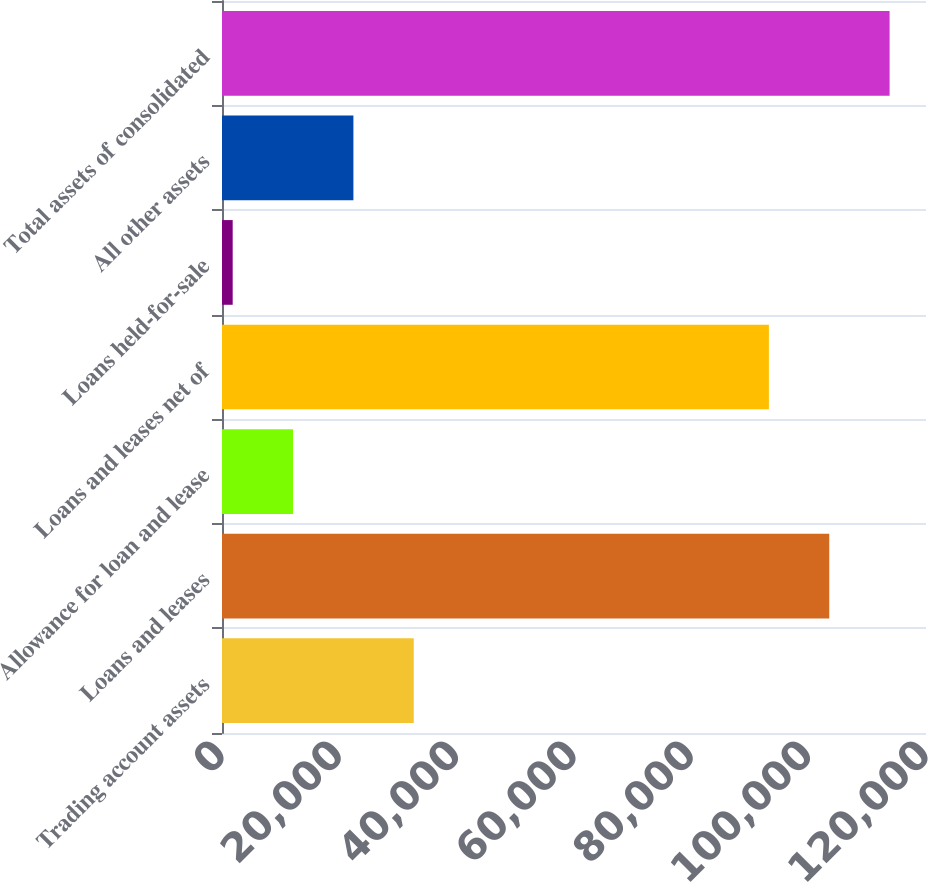<chart> <loc_0><loc_0><loc_500><loc_500><bar_chart><fcel>Trading account assets<fcel>Loans and leases<fcel>Allowance for loan and lease<fcel>Loans and leases net of<fcel>Loans held-for-sale<fcel>All other assets<fcel>Total assets of consolidated<nl><fcel>32685.4<fcel>103507<fcel>12109.8<fcel>93219<fcel>1822<fcel>22397.6<fcel>113795<nl></chart> 